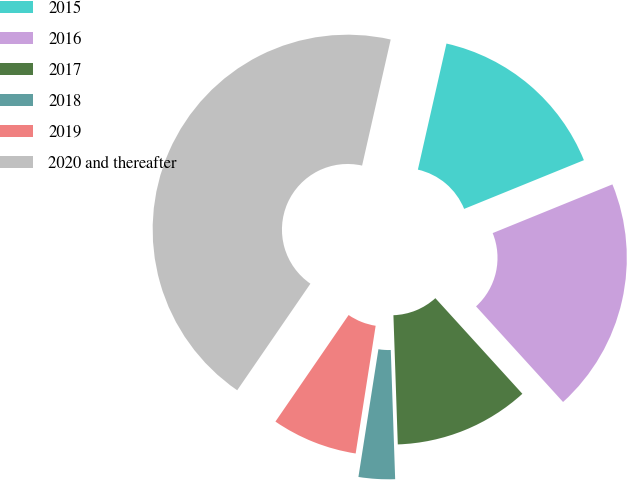<chart> <loc_0><loc_0><loc_500><loc_500><pie_chart><fcel>2015<fcel>2016<fcel>2017<fcel>2018<fcel>2019<fcel>2020 and thereafter<nl><fcel>15.3%<fcel>19.4%<fcel>11.21%<fcel>3.01%<fcel>7.11%<fcel>43.97%<nl></chart> 